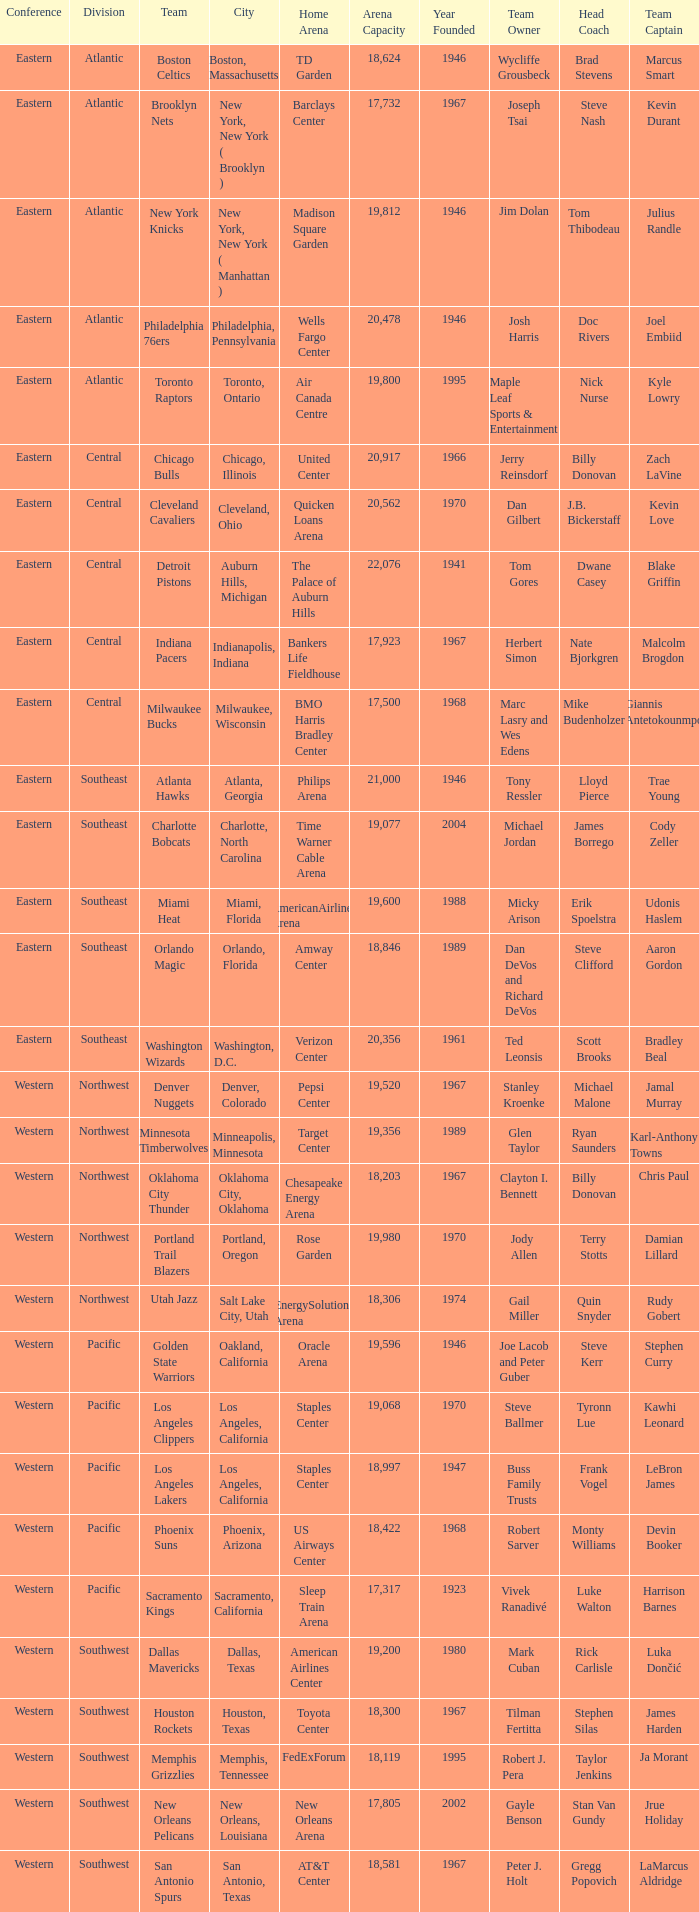Would you be able to parse every entry in this table? {'header': ['Conference', 'Division', 'Team', 'City', 'Home Arena', 'Arena Capacity', 'Year Founded', 'Team Owner', 'Head Coach', 'Team Captain'], 'rows': [['Eastern', 'Atlantic', 'Boston Celtics', 'Boston, Massachusetts', 'TD Garden', '18,624', '1946', 'Wycliffe Grousbeck', 'Brad Stevens', 'Marcus Smart'], ['Eastern', 'Atlantic', 'Brooklyn Nets', 'New York, New York ( Brooklyn )', 'Barclays Center', '17,732', '1967', 'Joseph Tsai', 'Steve Nash', 'Kevin Durant'], ['Eastern', 'Atlantic', 'New York Knicks', 'New York, New York ( Manhattan )', 'Madison Square Garden', '19,812', '1946', 'Jim Dolan', 'Tom Thibodeau', 'Julius Randle'], ['Eastern', 'Atlantic', 'Philadelphia 76ers', 'Philadelphia, Pennsylvania', 'Wells Fargo Center', '20,478', '1946', 'Josh Harris', 'Doc Rivers', 'Joel Embiid'], ['Eastern', 'Atlantic', 'Toronto Raptors', 'Toronto, Ontario', 'Air Canada Centre', '19,800', '1995', 'Maple Leaf Sports & Entertainment', 'Nick Nurse', 'Kyle Lowry'], ['Eastern', 'Central', 'Chicago Bulls', 'Chicago, Illinois', 'United Center', '20,917', '1966', 'Jerry Reinsdorf', 'Billy Donovan', 'Zach LaVine'], ['Eastern', 'Central', 'Cleveland Cavaliers', 'Cleveland, Ohio', 'Quicken Loans Arena', '20,562', '1970', 'Dan Gilbert', 'J.B. Bickerstaff', 'Kevin Love'], ['Eastern', 'Central', 'Detroit Pistons', 'Auburn Hills, Michigan', 'The Palace of Auburn Hills', '22,076', '1941', 'Tom Gores', 'Dwane Casey', 'Blake Griffin'], ['Eastern', 'Central', 'Indiana Pacers', 'Indianapolis, Indiana', 'Bankers Life Fieldhouse', '17,923', '1967', 'Herbert Simon', 'Nate Bjorkgren', 'Malcolm Brogdon'], ['Eastern', 'Central', 'Milwaukee Bucks', 'Milwaukee, Wisconsin', 'BMO Harris Bradley Center', '17,500', '1968', 'Marc Lasry and Wes Edens', 'Mike Budenholzer', 'Giannis Antetokounmpo'], ['Eastern', 'Southeast', 'Atlanta Hawks', 'Atlanta, Georgia', 'Philips Arena', '21,000', '1946', 'Tony Ressler', 'Lloyd Pierce', 'Trae Young'], ['Eastern', 'Southeast', 'Charlotte Bobcats', 'Charlotte, North Carolina', 'Time Warner Cable Arena', '19,077', '2004', 'Michael Jordan', 'James Borrego', 'Cody Zeller'], ['Eastern', 'Southeast', 'Miami Heat', 'Miami, Florida', 'AmericanAirlines Arena', '19,600', '1988', 'Micky Arison', 'Erik Spoelstra', 'Udonis Haslem'], ['Eastern', 'Southeast', 'Orlando Magic', 'Orlando, Florida', 'Amway Center', '18,846', '1989', 'Dan DeVos and Richard DeVos', 'Steve Clifford', 'Aaron Gordon'], ['Eastern', 'Southeast', 'Washington Wizards', 'Washington, D.C.', 'Verizon Center', '20,356', '1961', 'Ted Leonsis', 'Scott Brooks', 'Bradley Beal'], ['Western', 'Northwest', 'Denver Nuggets', 'Denver, Colorado', 'Pepsi Center', '19,520', '1967', 'Stanley Kroenke', 'Michael Malone', 'Jamal Murray'], ['Western', 'Northwest', 'Minnesota Timberwolves', 'Minneapolis, Minnesota', 'Target Center', '19,356', '1989', 'Glen Taylor', 'Ryan Saunders', 'Karl-Anthony Towns'], ['Western', 'Northwest', 'Oklahoma City Thunder', 'Oklahoma City, Oklahoma', 'Chesapeake Energy Arena', '18,203', '1967', 'Clayton I. Bennett', 'Billy Donovan', 'Chris Paul'], ['Western', 'Northwest', 'Portland Trail Blazers', 'Portland, Oregon', 'Rose Garden', '19,980', '1970', 'Jody Allen', 'Terry Stotts', 'Damian Lillard'], ['Western', 'Northwest', 'Utah Jazz', 'Salt Lake City, Utah', 'EnergySolutions Arena', '18,306', '1974', 'Gail Miller', 'Quin Snyder', 'Rudy Gobert'], ['Western', 'Pacific', 'Golden State Warriors', 'Oakland, California', 'Oracle Arena', '19,596', '1946', 'Joe Lacob and Peter Guber', 'Steve Kerr', 'Stephen Curry'], ['Western', 'Pacific', 'Los Angeles Clippers', 'Los Angeles, California', 'Staples Center', '19,068', '1970', 'Steve Ballmer', 'Tyronn Lue', 'Kawhi Leonard'], ['Western', 'Pacific', 'Los Angeles Lakers', 'Los Angeles, California', 'Staples Center', '18,997', '1947', 'Buss Family Trusts', 'Frank Vogel', 'LeBron James'], ['Western', 'Pacific', 'Phoenix Suns', 'Phoenix, Arizona', 'US Airways Center', '18,422', '1968', 'Robert Sarver', 'Monty Williams', 'Devin Booker'], ['Western', 'Pacific', 'Sacramento Kings', 'Sacramento, California', 'Sleep Train Arena', '17,317', '1923', 'Vivek Ranadivé', 'Luke Walton', 'Harrison Barnes'], ['Western', 'Southwest', 'Dallas Mavericks', 'Dallas, Texas', 'American Airlines Center', '19,200', '1980', 'Mark Cuban', 'Rick Carlisle', 'Luka Dončić'], ['Western', 'Southwest', 'Houston Rockets', 'Houston, Texas', 'Toyota Center', '18,300', '1967', 'Tilman Fertitta', 'Stephen Silas', 'James Harden'], ['Western', 'Southwest', 'Memphis Grizzlies', 'Memphis, Tennessee', 'FedExForum', '18,119', '1995', 'Robert J. Pera', 'Taylor Jenkins', 'Ja Morant'], ['Western', 'Southwest', 'New Orleans Pelicans', 'New Orleans, Louisiana', 'New Orleans Arena', '17,805', '2002', 'Gayle Benson', 'Stan Van Gundy', 'Jrue Holiday'], ['Western', 'Southwest', 'San Antonio Spurs', 'San Antonio, Texas', 'AT&T Center', '18,581', '1967', 'Peter J. Holt', 'Gregg Popovich', 'LaMarcus Aldridge']]} Which city includes the Target Center arena? Minneapolis, Minnesota. 